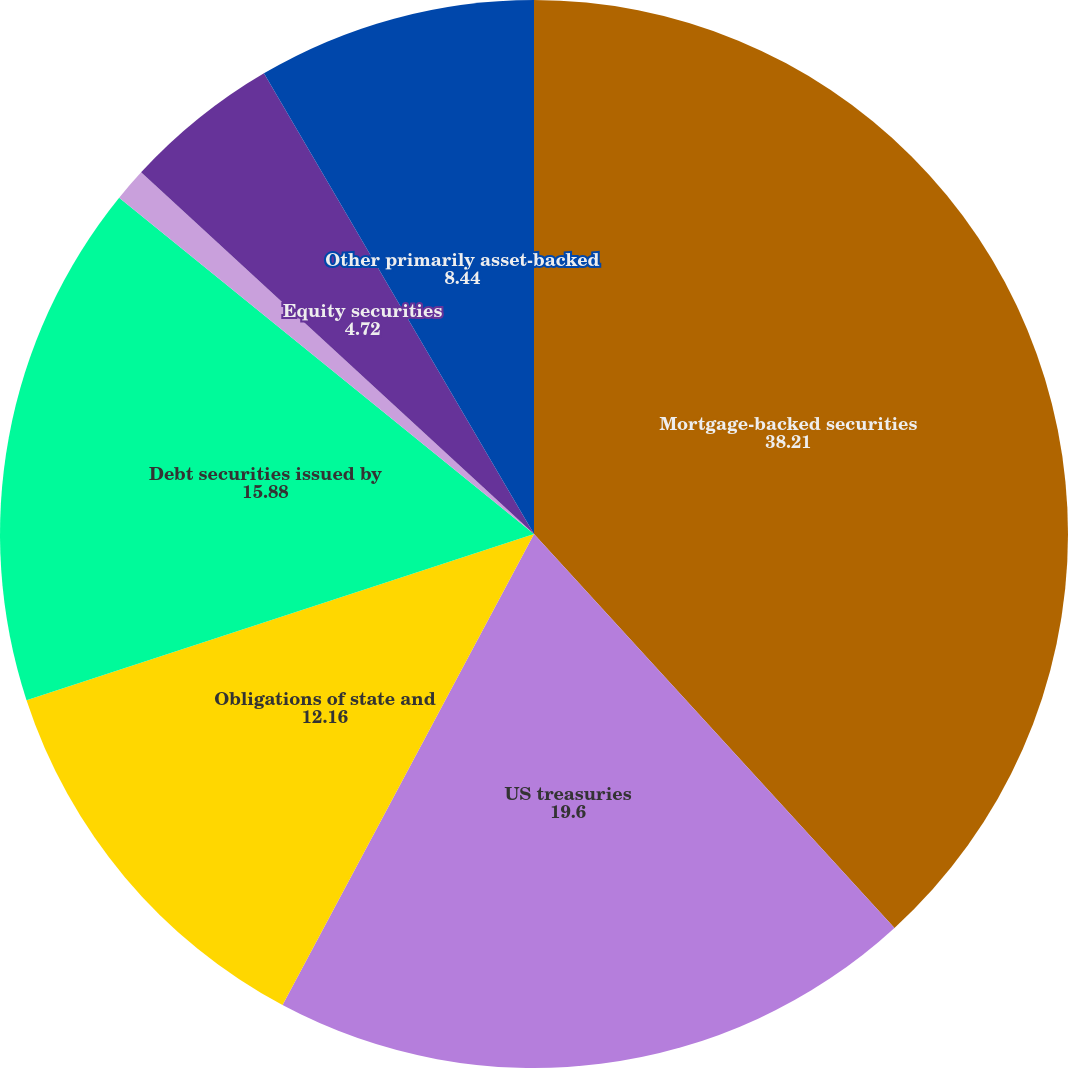Convert chart. <chart><loc_0><loc_0><loc_500><loc_500><pie_chart><fcel>Mortgage-backed securities<fcel>US treasuries<fcel>Obligations of state and<fcel>Debt securities issued by<fcel>Corporate debt securities<fcel>Equity securities<fcel>Other primarily asset-backed<nl><fcel>38.21%<fcel>19.6%<fcel>12.16%<fcel>15.88%<fcel>1.0%<fcel>4.72%<fcel>8.44%<nl></chart> 